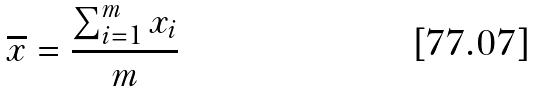Convert formula to latex. <formula><loc_0><loc_0><loc_500><loc_500>\overline { x } = \frac { \sum _ { i = 1 } ^ { m } x _ { i } } { m }</formula> 